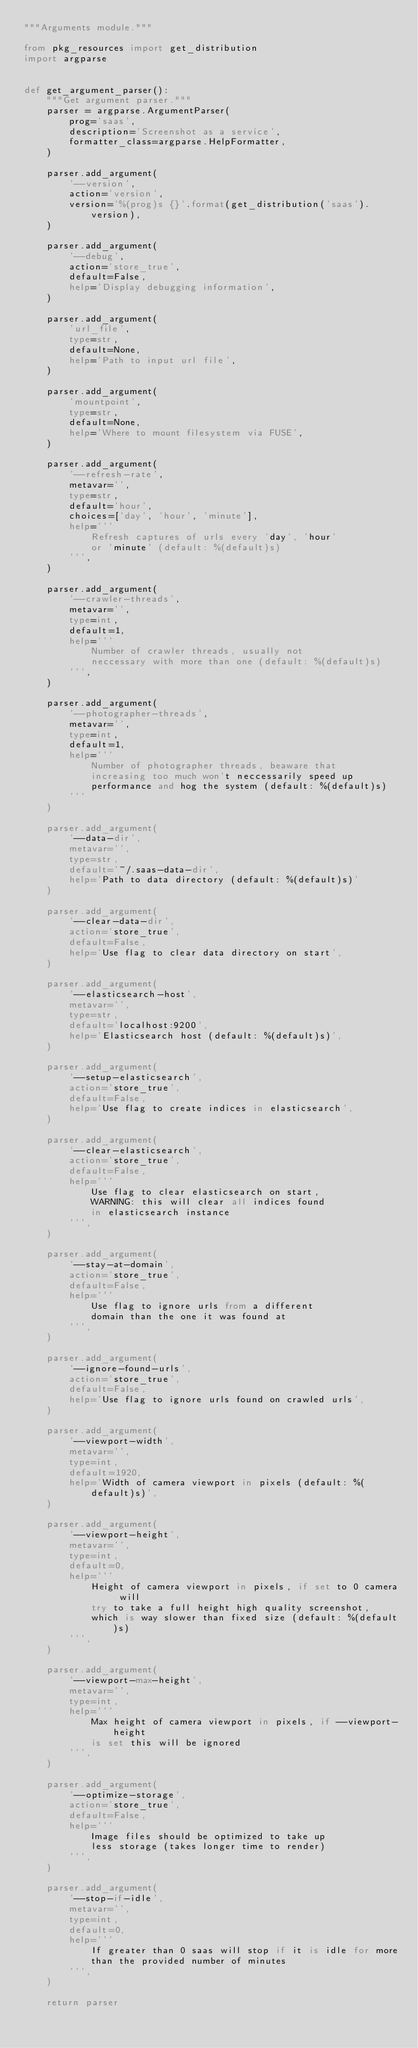Convert code to text. <code><loc_0><loc_0><loc_500><loc_500><_Python_>"""Arguments module."""

from pkg_resources import get_distribution
import argparse


def get_argument_parser():
    """Get argument parser."""
    parser = argparse.ArgumentParser(
        prog='saas',
        description='Screenshot as a service',
        formatter_class=argparse.HelpFormatter,
    )

    parser.add_argument(
        '--version',
        action='version',
        version='%(prog)s {}'.format(get_distribution('saas').version),
    )

    parser.add_argument(
        '--debug',
        action='store_true',
        default=False,
        help='Display debugging information',
    )

    parser.add_argument(
        'url_file',
        type=str,
        default=None,
        help='Path to input url file',
    )

    parser.add_argument(
        'mountpoint',
        type=str,
        default=None,
        help='Where to mount filesystem via FUSE',
    )

    parser.add_argument(
        '--refresh-rate',
        metavar='',
        type=str,
        default='hour',
        choices=['day', 'hour', 'minute'],
        help='''
            Refresh captures of urls every 'day', 'hour'
            or 'minute' (default: %(default)s)
        ''',
    )

    parser.add_argument(
        '--crawler-threads',
        metavar='',
        type=int,
        default=1,
        help='''
            Number of crawler threads, usually not
            neccessary with more than one (default: %(default)s)
        ''',
    )

    parser.add_argument(
        '--photographer-threads',
        metavar='',
        type=int,
        default=1,
        help='''
            Number of photographer threads, beaware that
            increasing too much won't neccessarily speed up
            performance and hog the system (default: %(default)s)
        '''
    )

    parser.add_argument(
        '--data-dir',
        metavar='',
        type=str,
        default='~/.saas-data-dir',
        help='Path to data directory (default: %(default)s)'
    )

    parser.add_argument(
        '--clear-data-dir',
        action='store_true',
        default=False,
        help='Use flag to clear data directory on start',
    )

    parser.add_argument(
        '--elasticsearch-host',
        metavar='',
        type=str,
        default='localhost:9200',
        help='Elasticsearch host (default: %(default)s)',
    )

    parser.add_argument(
        '--setup-elasticsearch',
        action='store_true',
        default=False,
        help='Use flag to create indices in elasticsearch',
    )

    parser.add_argument(
        '--clear-elasticsearch',
        action='store_true',
        default=False,
        help='''
            Use flag to clear elasticsearch on start,
            WARNING: this will clear all indices found
            in elasticsearch instance
        ''',
    )

    parser.add_argument(
        '--stay-at-domain',
        action='store_true',
        default=False,
        help='''
            Use flag to ignore urls from a different
            domain than the one it was found at
        ''',
    )

    parser.add_argument(
        '--ignore-found-urls',
        action='store_true',
        default=False,
        help='Use flag to ignore urls found on crawled urls',
    )

    parser.add_argument(
        '--viewport-width',
        metavar='',
        type=int,
        default=1920,
        help='Width of camera viewport in pixels (default: %(default)s)',
    )

    parser.add_argument(
        '--viewport-height',
        metavar='',
        type=int,
        default=0,
        help='''
            Height of camera viewport in pixels, if set to 0 camera will
            try to take a full height high quality screenshot,
            which is way slower than fixed size (default: %(default)s)
        ''',
    )

    parser.add_argument(
        '--viewport-max-height',
        metavar='',
        type=int,
        help='''
            Max height of camera viewport in pixels, if --viewport-height
            is set this will be ignored
        ''',
    )

    parser.add_argument(
        '--optimize-storage',
        action='store_true',
        default=False,
        help='''
            Image files should be optimized to take up
            less storage (takes longer time to render)
        ''',
    )

    parser.add_argument(
        '--stop-if-idle',
        metavar='',
        type=int,
        default=0,
        help='''
            If greater than 0 saas will stop if it is idle for more
            than the provided number of minutes
        ''',
    )

    return parser
</code> 